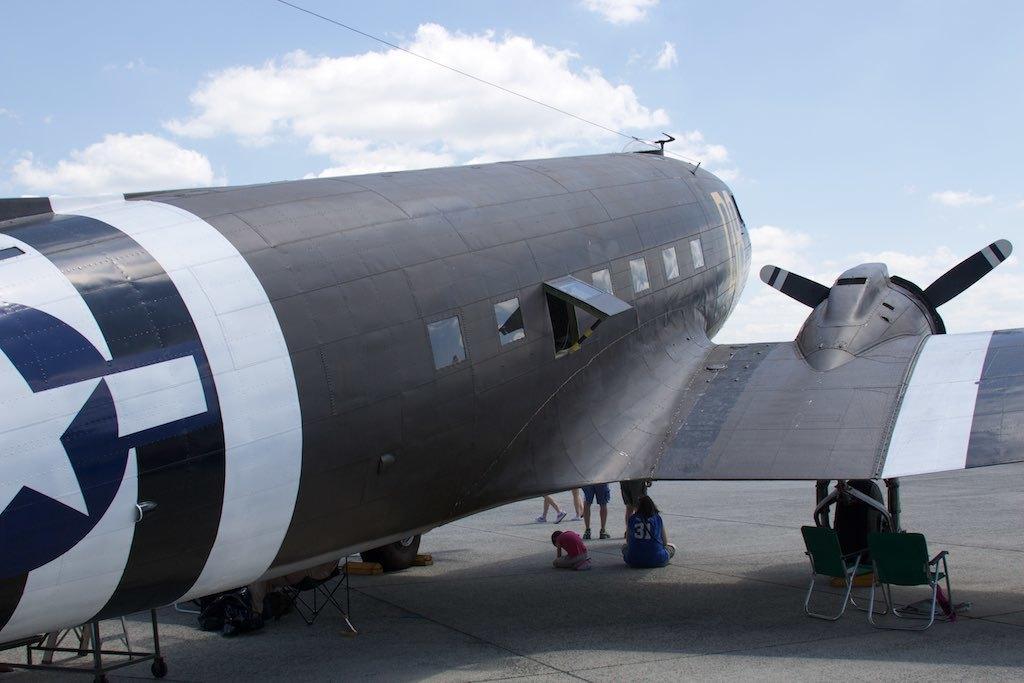Please provide a concise description of this image. In this image in front there is an airplane. There are chairs. There are two people sitting under the airplane. There are a few people standing. In the background of the image there is sky. 